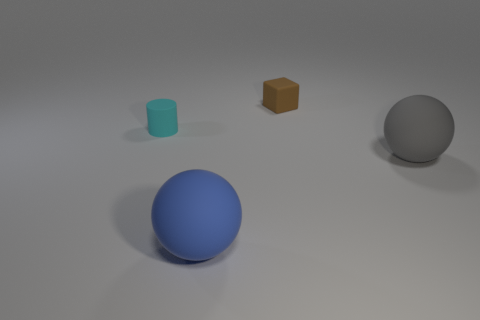Add 1 big yellow metal objects. How many objects exist? 5 Subtract all gray balls. How many balls are left? 1 Subtract 1 spheres. How many spheres are left? 1 Subtract all cylinders. How many objects are left? 3 Subtract all purple cylinders. Subtract all yellow blocks. How many cylinders are left? 1 Subtract all yellow cylinders. How many blue cubes are left? 0 Subtract all tiny red objects. Subtract all tiny brown rubber cubes. How many objects are left? 3 Add 1 gray objects. How many gray objects are left? 2 Add 4 brown matte objects. How many brown matte objects exist? 5 Subtract 0 yellow cubes. How many objects are left? 4 